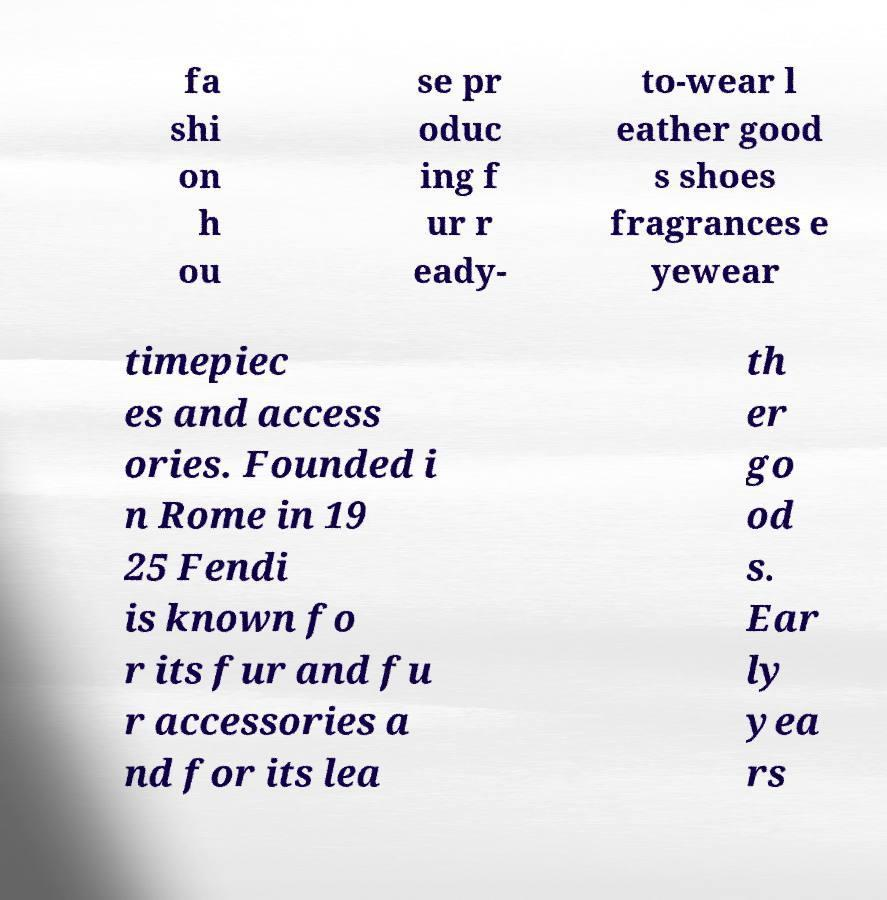Can you accurately transcribe the text from the provided image for me? fa shi on h ou se pr oduc ing f ur r eady- to-wear l eather good s shoes fragrances e yewear timepiec es and access ories. Founded i n Rome in 19 25 Fendi is known fo r its fur and fu r accessories a nd for its lea th er go od s. Ear ly yea rs 